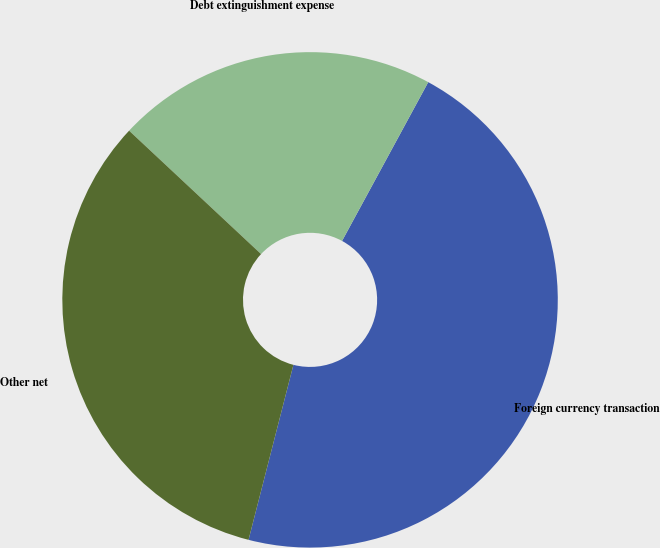<chart> <loc_0><loc_0><loc_500><loc_500><pie_chart><fcel>Foreign currency transaction<fcel>Debt extinguishment expense<fcel>Other net<nl><fcel>46.08%<fcel>20.95%<fcel>32.97%<nl></chart> 